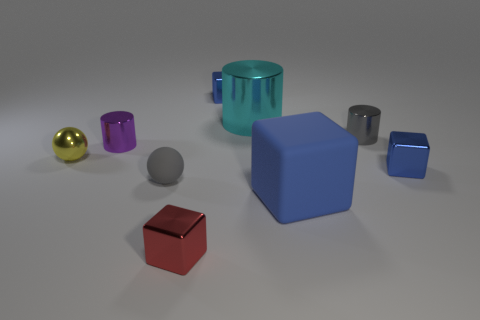How many blue blocks must be subtracted to get 1 blue blocks? 2 Subtract all gray balls. How many blue blocks are left? 3 Subtract 1 blocks. How many blocks are left? 3 Subtract all cyan blocks. Subtract all green cylinders. How many blocks are left? 4 Add 1 big blue matte cubes. How many objects exist? 10 Subtract all cylinders. How many objects are left? 6 Subtract 0 blue balls. How many objects are left? 9 Subtract all cyan cylinders. Subtract all cylinders. How many objects are left? 5 Add 7 large matte objects. How many large matte objects are left? 8 Add 8 tiny green metal blocks. How many tiny green metal blocks exist? 8 